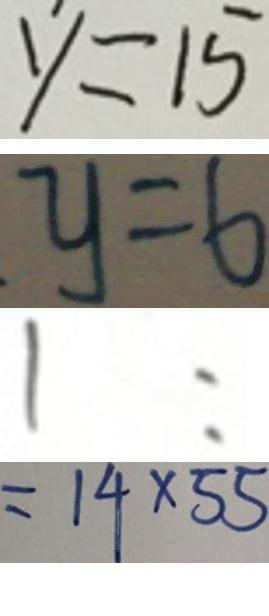Convert formula to latex. <formula><loc_0><loc_0><loc_500><loc_500>y = 1 5 
 y = 6 
 1 : 
 = 1 4 \times 5 5</formula> 